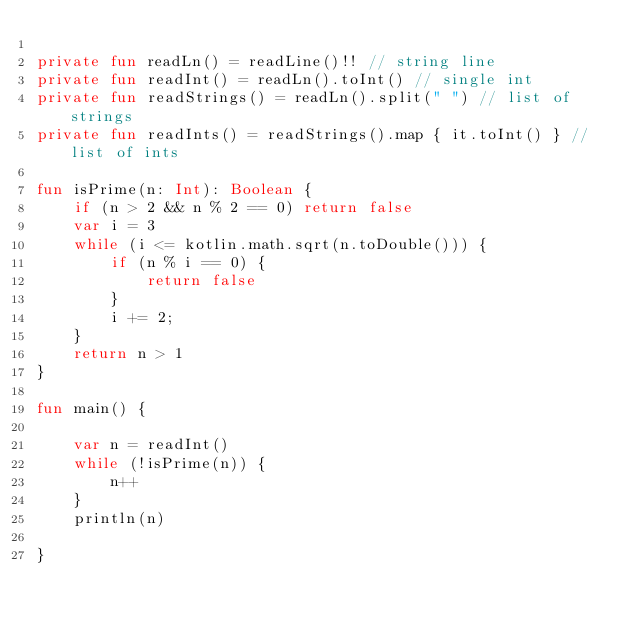Convert code to text. <code><loc_0><loc_0><loc_500><loc_500><_Kotlin_>
private fun readLn() = readLine()!! // string line
private fun readInt() = readLn().toInt() // single int
private fun readStrings() = readLn().split(" ") // list of strings
private fun readInts() = readStrings().map { it.toInt() } // list of ints

fun isPrime(n: Int): Boolean {
    if (n > 2 && n % 2 == 0) return false
    var i = 3
    while (i <= kotlin.math.sqrt(n.toDouble())) {
        if (n % i == 0) {
            return false
        }
        i += 2;
    }
    return n > 1
}

fun main() {

    var n = readInt()
    while (!isPrime(n)) {
        n++
    }
    println(n)

}

</code> 